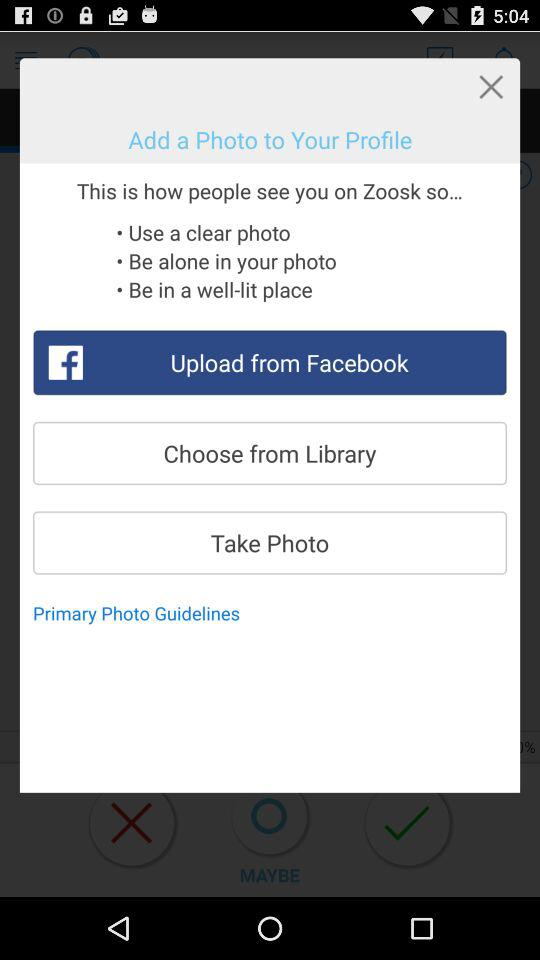How many of the guidelines are about being alone in the photo?
Answer the question using a single word or phrase. 1 